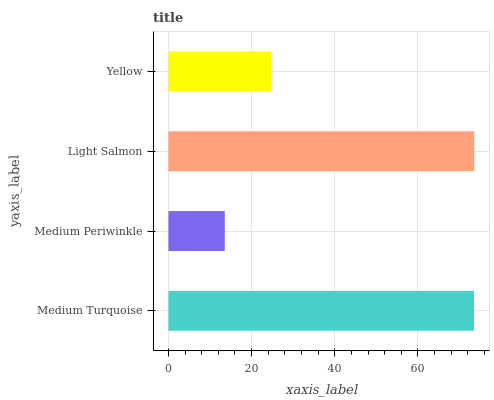Is Medium Periwinkle the minimum?
Answer yes or no. Yes. Is Light Salmon the maximum?
Answer yes or no. Yes. Is Light Salmon the minimum?
Answer yes or no. No. Is Medium Periwinkle the maximum?
Answer yes or no. No. Is Light Salmon greater than Medium Periwinkle?
Answer yes or no. Yes. Is Medium Periwinkle less than Light Salmon?
Answer yes or no. Yes. Is Medium Periwinkle greater than Light Salmon?
Answer yes or no. No. Is Light Salmon less than Medium Periwinkle?
Answer yes or no. No. Is Medium Turquoise the high median?
Answer yes or no. Yes. Is Yellow the low median?
Answer yes or no. Yes. Is Light Salmon the high median?
Answer yes or no. No. Is Medium Turquoise the low median?
Answer yes or no. No. 